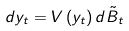<formula> <loc_0><loc_0><loc_500><loc_500>d y _ { t } = V \left ( y _ { t } \right ) d \tilde { B } _ { t }</formula> 